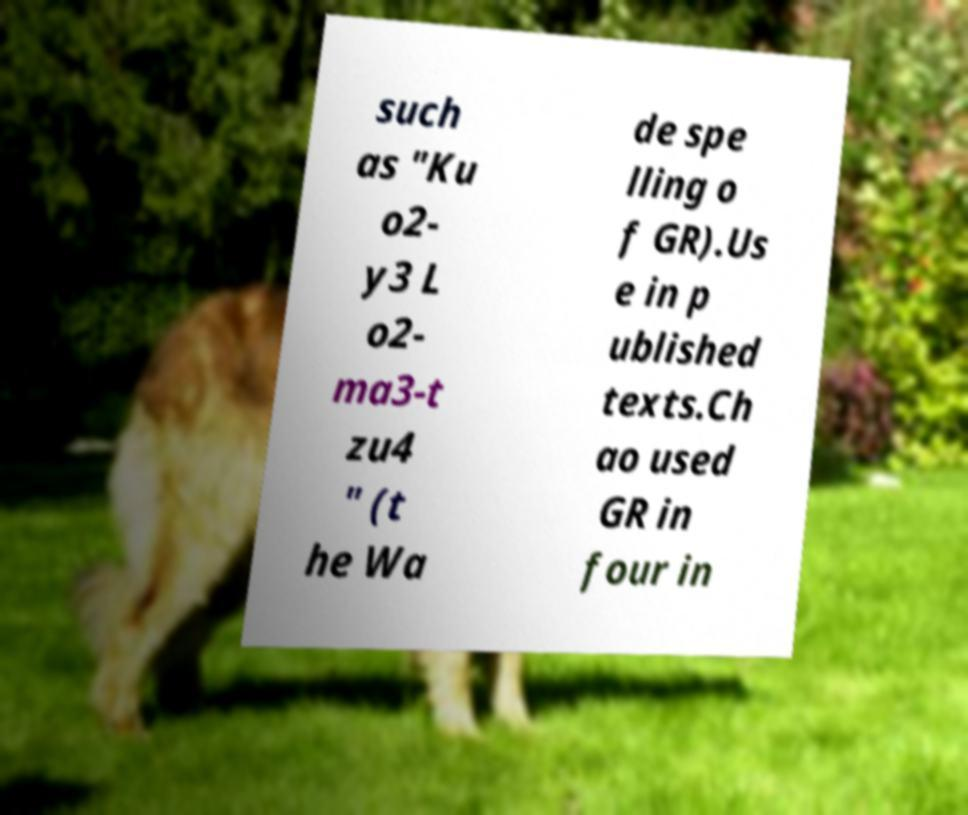Could you extract and type out the text from this image? such as "Ku o2- y3 L o2- ma3-t zu4 " (t he Wa de spe lling o f GR).Us e in p ublished texts.Ch ao used GR in four in 